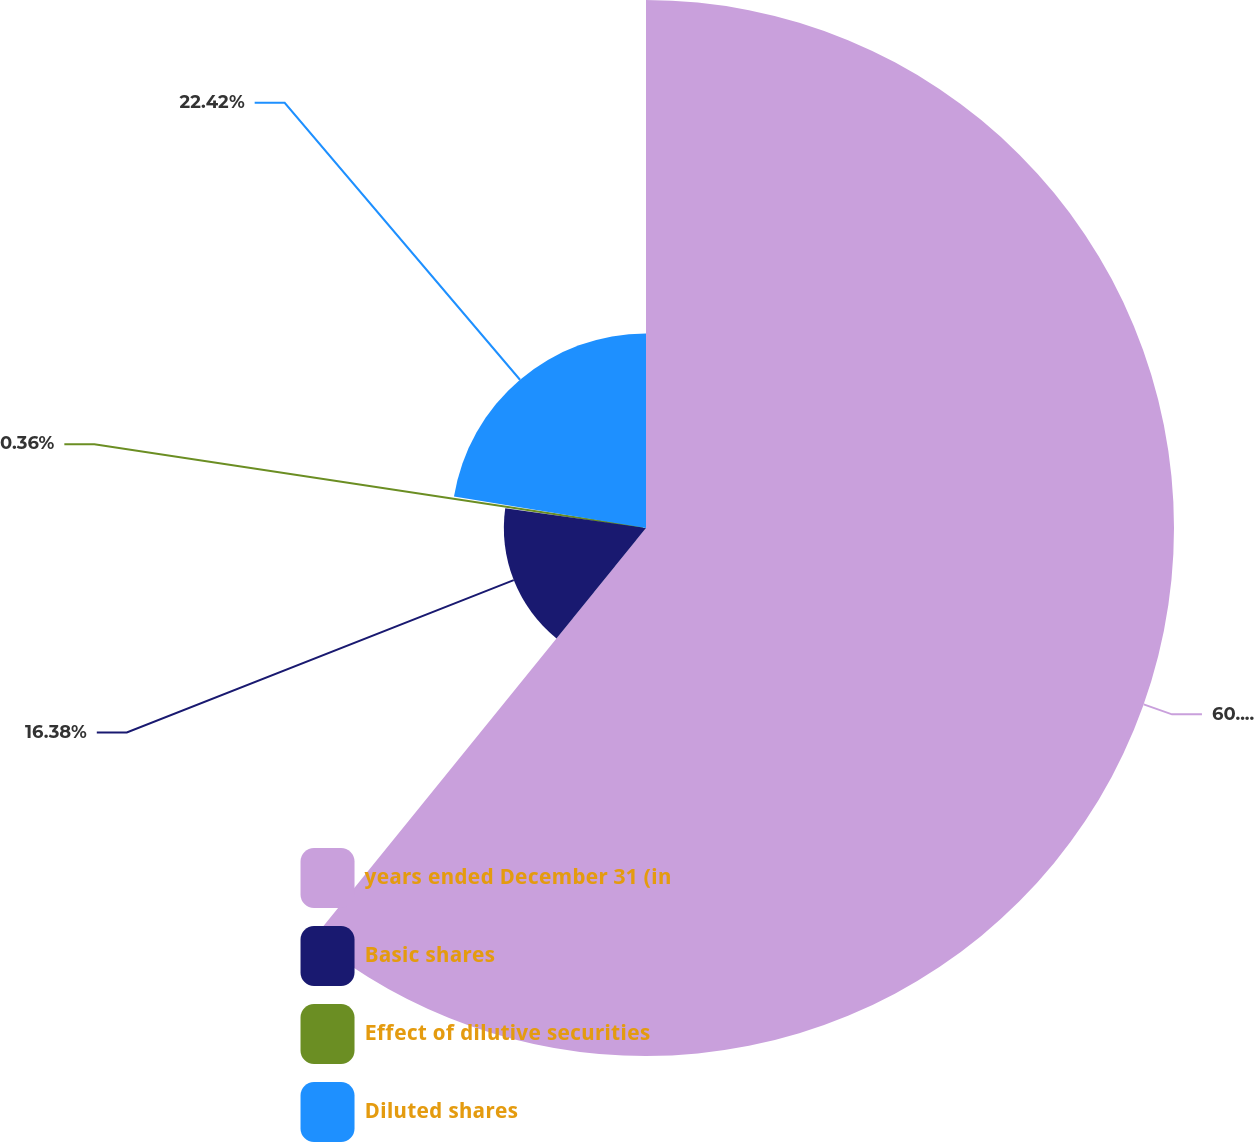<chart> <loc_0><loc_0><loc_500><loc_500><pie_chart><fcel>years ended December 31 (in<fcel>Basic shares<fcel>Effect of dilutive securities<fcel>Diluted shares<nl><fcel>60.84%<fcel>16.38%<fcel>0.36%<fcel>22.42%<nl></chart> 